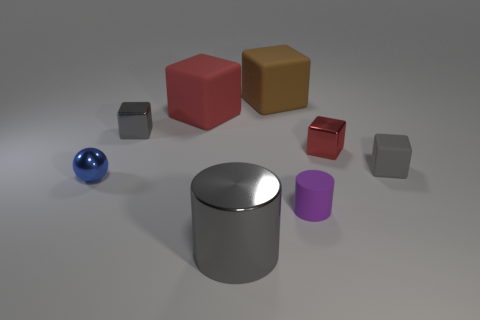Is there anything else that is the same shape as the blue thing?
Your answer should be very brief. No. There is a gray metal block; are there any tiny blue metallic spheres to the right of it?
Keep it short and to the point. No. There is a blue metallic object; is its shape the same as the small gray thing to the right of the tiny purple rubber object?
Make the answer very short. No. What is the color of the tiny block that is the same material as the tiny cylinder?
Offer a terse response. Gray. What is the color of the small sphere?
Provide a succinct answer. Blue. Are the purple thing and the red object that is on the right side of the big cylinder made of the same material?
Keep it short and to the point. No. What number of cubes are both to the right of the large red thing and to the left of the gray shiny cylinder?
Make the answer very short. 0. What is the shape of the rubber object that is the same size as the brown cube?
Provide a succinct answer. Cube. Is there a gray cube that is to the left of the big matte block in front of the large matte thing that is to the right of the red matte block?
Your response must be concise. Yes. Is the color of the metallic ball the same as the matte block on the left side of the large gray object?
Offer a terse response. No. 